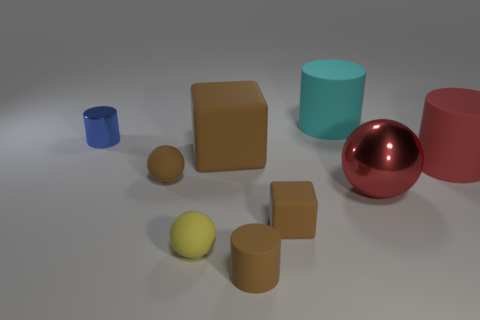What shape is the big thing that is the same color as the large ball?
Your answer should be compact. Cylinder. Is the small shiny thing the same color as the metallic sphere?
Ensure brevity in your answer.  No. How many things are large brown metallic objects or balls behind the metallic sphere?
Your response must be concise. 1. Is there another object that has the same size as the red rubber object?
Provide a short and direct response. Yes. Is the material of the red cylinder the same as the tiny cube?
Provide a short and direct response. Yes. What number of objects are brown blocks or tiny gray matte cylinders?
Offer a very short reply. 2. The brown rubber sphere is what size?
Provide a succinct answer. Small. Are there fewer large metallic balls than small cyan matte cubes?
Provide a short and direct response. No. What number of tiny cubes have the same color as the small matte cylinder?
Your answer should be compact. 1. There is a cube that is in front of the large red cylinder; is its color the same as the large sphere?
Your response must be concise. No. 